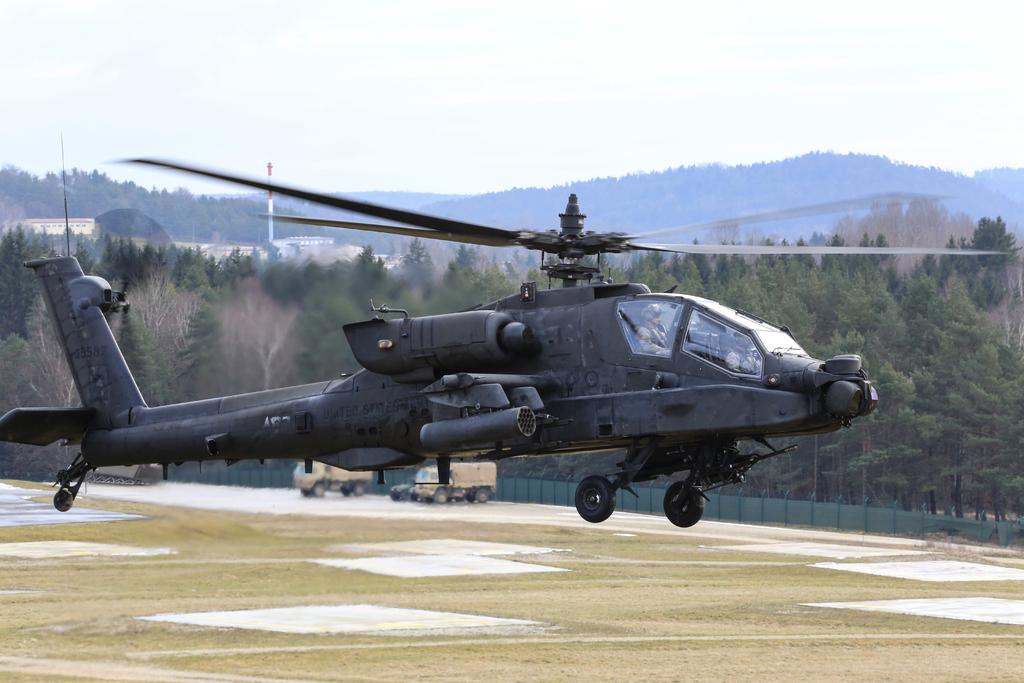What is the main subject in the center of the image? There is a black color helicopter in the center of the image. What type of terrain is visible at the bottom of the image? There is grass at the bottom of the image. What can be seen in the background of the image? There are mountains, trees, and the sky visible in the background of the image. What type of skirt is the helicopter wearing in the image? Helicopters do not wear skirts; they are machines and do not have clothing. 